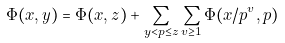Convert formula to latex. <formula><loc_0><loc_0><loc_500><loc_500>\Phi ( x , y ) = \Phi ( x , z ) + \sum _ { y < p \leq z } \sum _ { v \geq 1 } \Phi ( x / p ^ { v } , p )</formula> 